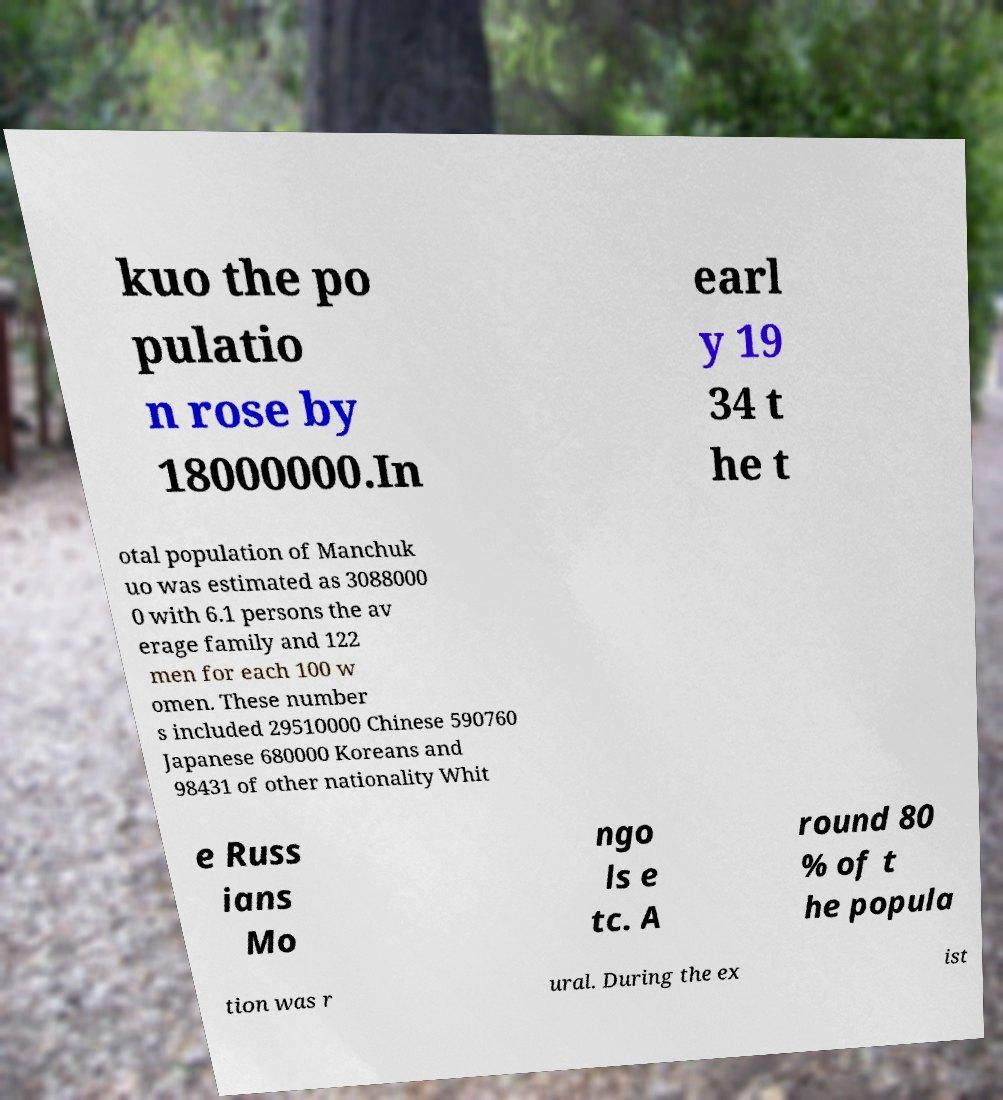Please read and relay the text visible in this image. What does it say? kuo the po pulatio n rose by 18000000.In earl y 19 34 t he t otal population of Manchuk uo was estimated as 3088000 0 with 6.1 persons the av erage family and 122 men for each 100 w omen. These number s included 29510000 Chinese 590760 Japanese 680000 Koreans and 98431 of other nationality Whit e Russ ians Mo ngo ls e tc. A round 80 % of t he popula tion was r ural. During the ex ist 